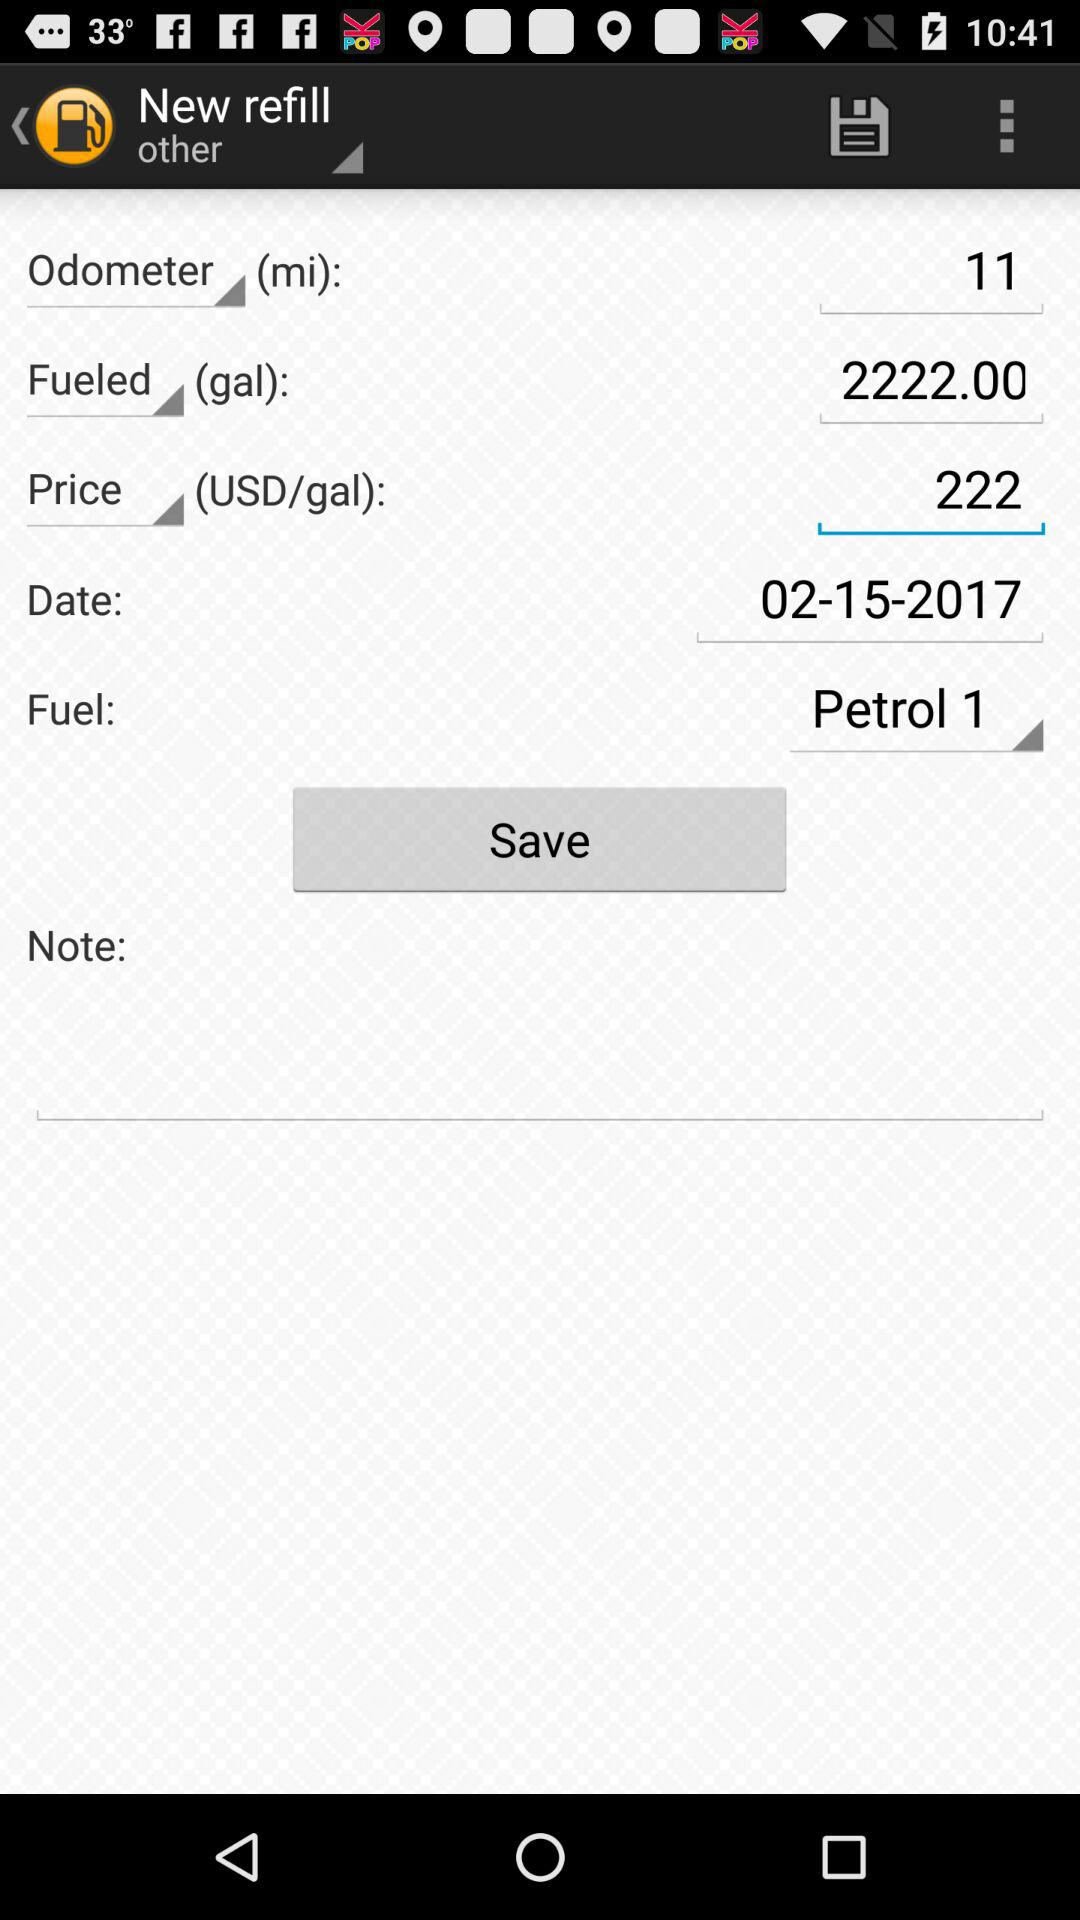What is the selected date? The selected date is February 15, 2017. 